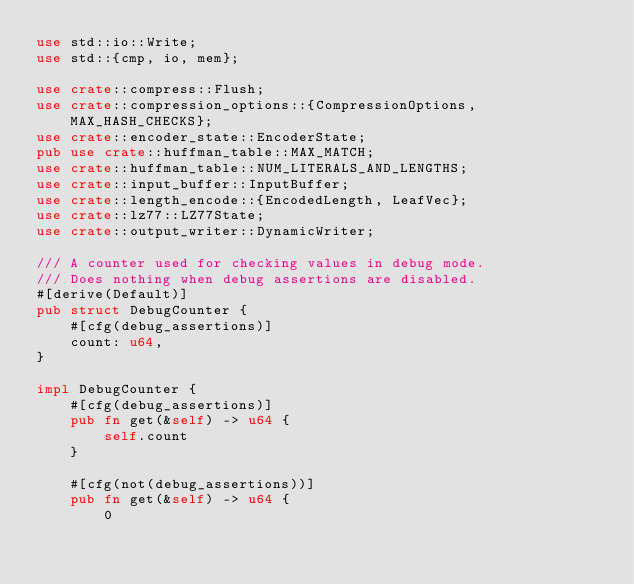Convert code to text. <code><loc_0><loc_0><loc_500><loc_500><_Rust_>use std::io::Write;
use std::{cmp, io, mem};

use crate::compress::Flush;
use crate::compression_options::{CompressionOptions, MAX_HASH_CHECKS};
use crate::encoder_state::EncoderState;
pub use crate::huffman_table::MAX_MATCH;
use crate::huffman_table::NUM_LITERALS_AND_LENGTHS;
use crate::input_buffer::InputBuffer;
use crate::length_encode::{EncodedLength, LeafVec};
use crate::lz77::LZ77State;
use crate::output_writer::DynamicWriter;

/// A counter used for checking values in debug mode.
/// Does nothing when debug assertions are disabled.
#[derive(Default)]
pub struct DebugCounter {
    #[cfg(debug_assertions)]
    count: u64,
}

impl DebugCounter {
    #[cfg(debug_assertions)]
    pub fn get(&self) -> u64 {
        self.count
    }

    #[cfg(not(debug_assertions))]
    pub fn get(&self) -> u64 {
        0</code> 